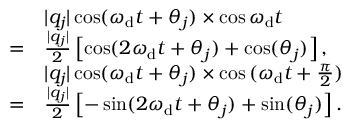Convert formula to latex. <formula><loc_0><loc_0><loc_500><loc_500>\begin{array} { r l } & { | q _ { j } | \cos ( \omega _ { d } t + \theta _ { j } ) \times \cos { \omega _ { d } t } } \\ { = } & { \frac { | q _ { j } | } { 2 } \left [ \cos ( 2 \omega _ { d } t + \theta _ { j } ) + \cos ( \theta _ { j } ) \right ] , } \\ & { | q _ { j } | \cos ( \omega _ { d } t + \theta _ { j } ) \times \cos { ( \omega _ { d } t + \frac { \pi } { 2 } ) } } \\ { = } & { \frac { | q _ { j } | } { 2 } \left [ - \sin ( 2 \omega _ { d } t + \theta _ { j } ) + \sin ( \theta _ { j } ) \right ] . } \end{array}</formula> 